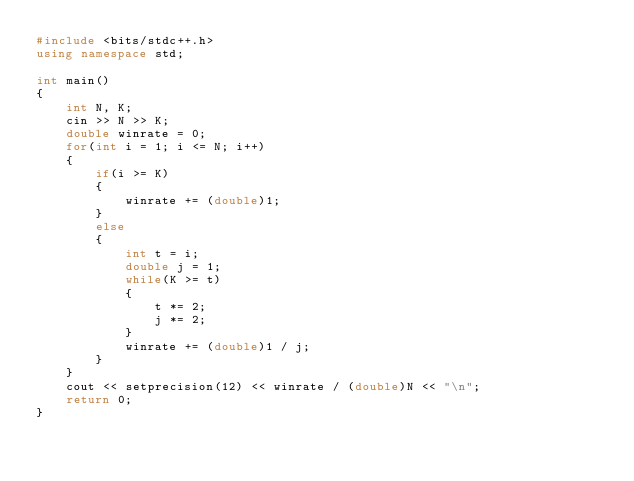Convert code to text. <code><loc_0><loc_0><loc_500><loc_500><_C++_>#include <bits/stdc++.h>
using namespace std;

int main()
{
    int N, K;
    cin >> N >> K;
    double winrate = 0;
    for(int i = 1; i <= N; i++)
    {
        if(i >= K)
        {
            winrate += (double)1;
        }
        else
        {
            int t = i;
            double j = 1;
            while(K >= t)
            {
                t *= 2;
                j *= 2;
            }
            winrate += (double)1 / j;
        }
    }
    cout << setprecision(12) << winrate / (double)N << "\n";
    return 0;
}</code> 